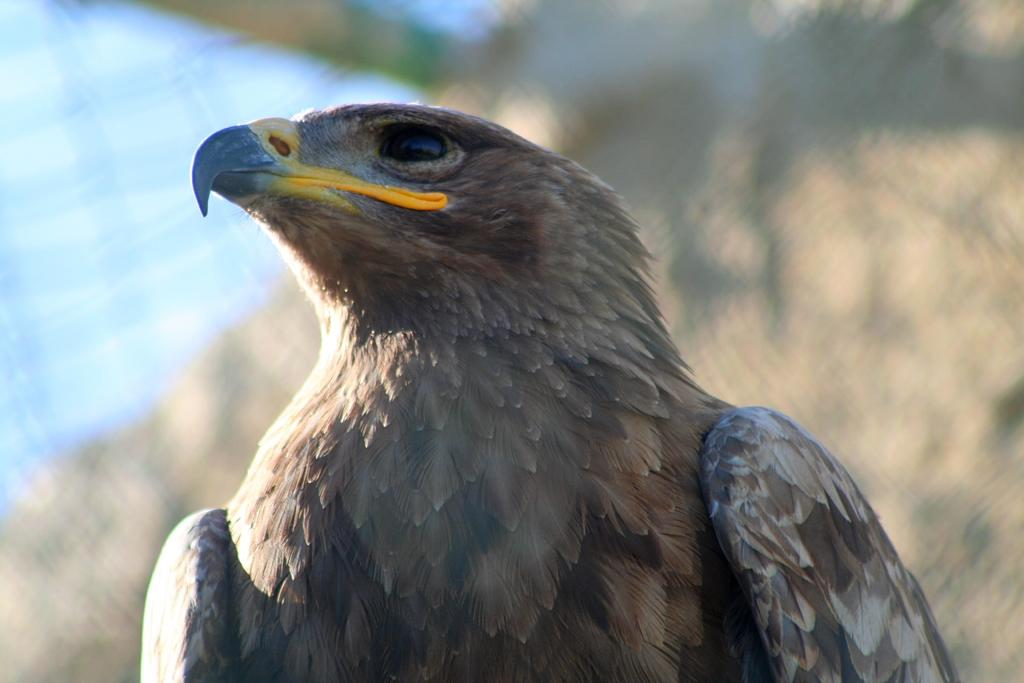What type of animal is present in the image? There is a bird in the image. Can you describe the background of the image? The background of the image is blurry. What type of fruit can be seen hanging from the branches of the trees in the image? There are no trees or fruit visible in the image; it only features a bird and a blurry background. 